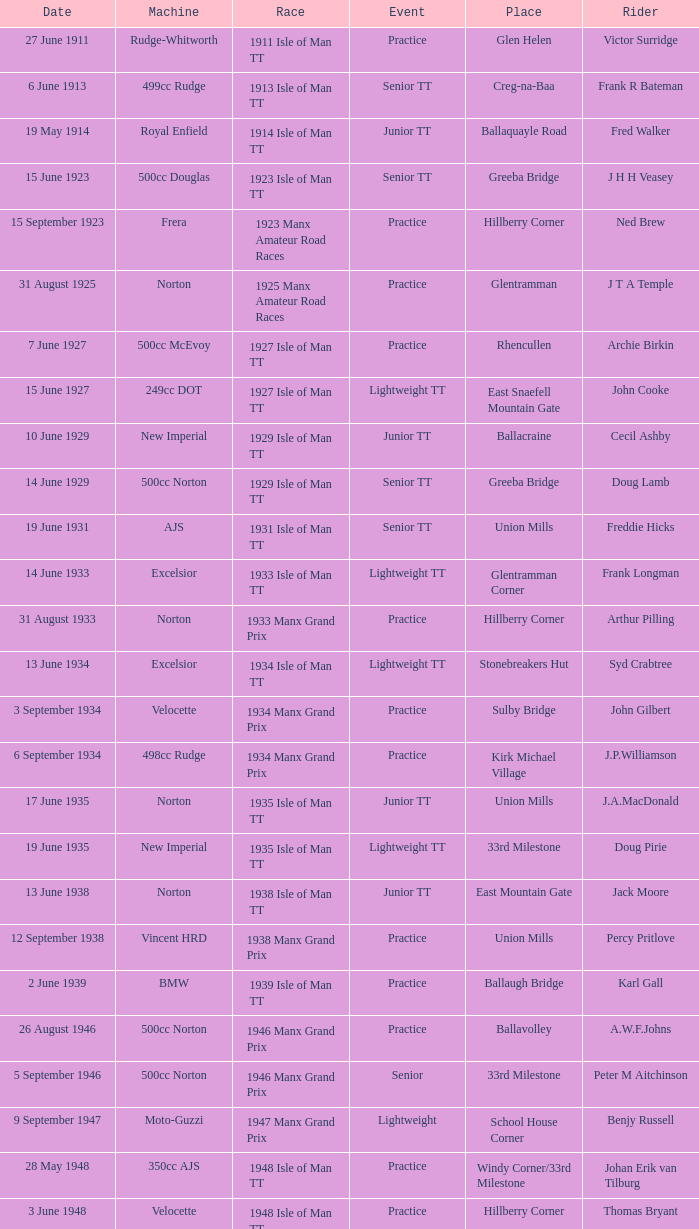Where was the 249cc Yamaha? Glentramman. 